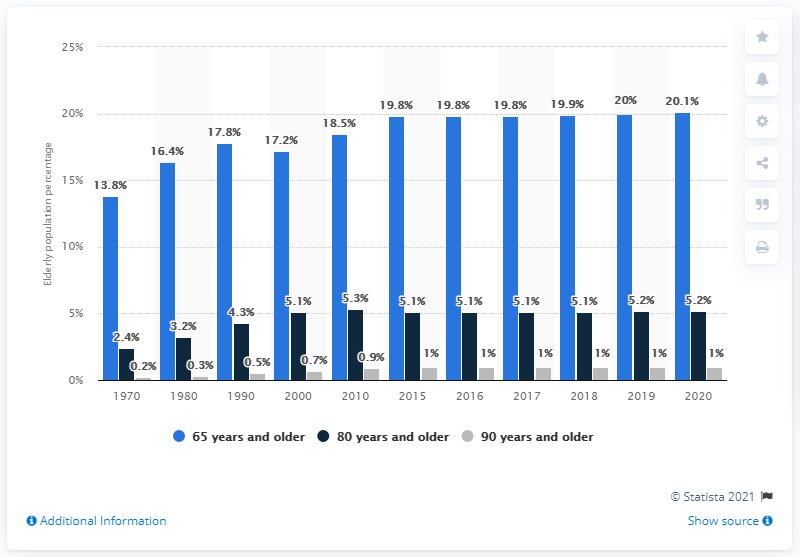Mention a couple of crucial points in this snapshot. In 2020, approximately 20.1% of the Swedish population was 65 years and older. 